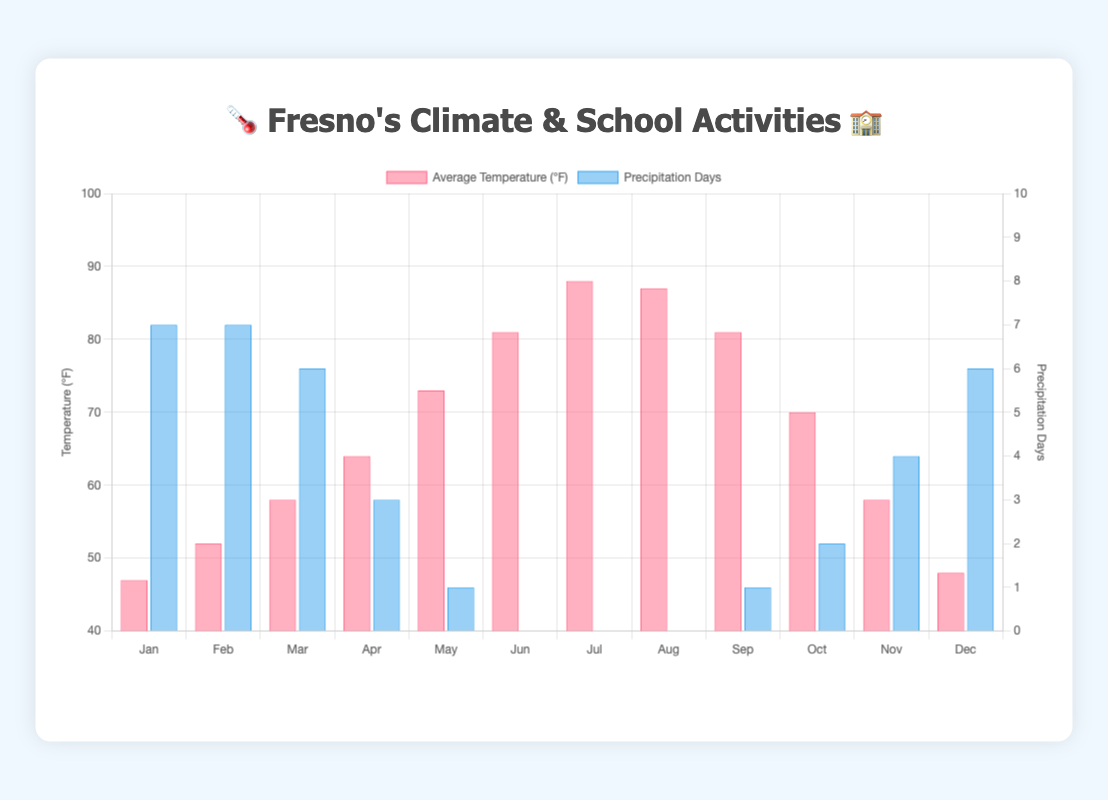What months have the highest and lowest average temperatures? The average temperatures are highest in July (88°F) and lowest in January (47°F). This can be observed from the temperature bars in the figure.
Answer: July, January What is the total number of precipitation days in a year? Add the precipitation days for each month: 7 + 7 + 6 + 3 + 1 + 0 + 0 + 0 + 1 + 2 + 4 + 6 = 37 days.
Answer: 37 Which month has the highest impact level on school activities? May has the highest impact level of 5, as shown in both the tooltip details and the number of stars.
Answer: May What is the range of average temperatures in the chart? The highest temperature is 88°F (July), and the lowest is 47°F (January). The range is 88 - 47 = 41°F.
Answer: 41°F How do the average temperatures in March and October compare? March has an average temperature of 58°F while October has 70°F. Therefore, October is warmer than March.
Answer: October is warmer Which months have 0 precipitation days, and what are their average temperatures? June (81°F), July (88°F), and August (87°F) all have 0 days of precipitation, as depicted by the blue bars.
Answer: June (81°F), July (88°F), August (87°F) During which month does the "Back to School Night 🌙" activity occur, and what is the average temperature of that month? The "Back to School Night 🌙" activity is in September when the average temperature is 81°F. This is shown in the tooltip details.
Answer: September, 81°F What is the impact level of activities in months with more than 5 precipitation days? January (7 days) and February (7 days) have an impact level of 2 and 1, respectively. December (6 days) has an impact level of 3.
Answer: January (2), February (1), December (3) Does the month with the "Thanksgiving Play 🦃" have more or fewer precipitation days than the month with the "Back to School Night 🌙"? The "Thanksgiving Play 🦃" in November has 4 precipitation days, while the "Back to School Night 🌙" in September has 1 day. November has more precipitation days than September.
Answer: November has more 